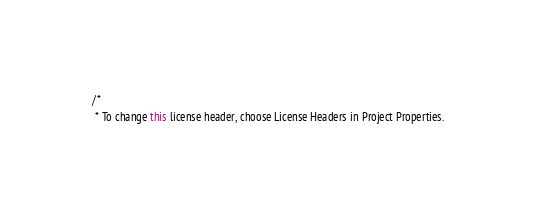<code> <loc_0><loc_0><loc_500><loc_500><_Java_>/*
 * To change this license header, choose License Headers in Project Properties.</code> 